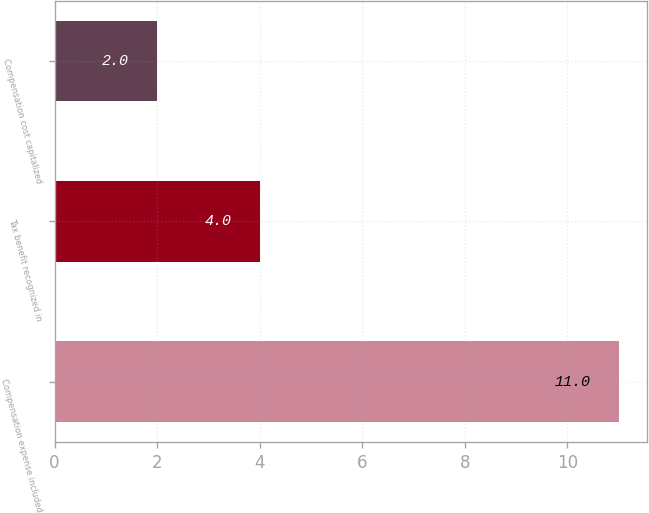Convert chart. <chart><loc_0><loc_0><loc_500><loc_500><bar_chart><fcel>Compensation expense included<fcel>Tax benefit recognized in<fcel>Compensation cost capitalized<nl><fcel>11<fcel>4<fcel>2<nl></chart> 